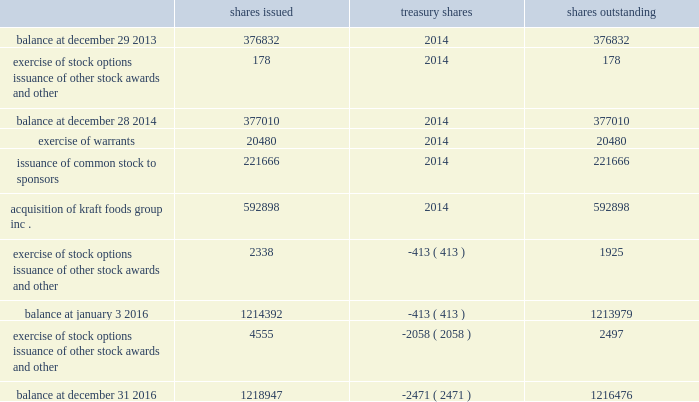Shares of common stock issued , in treasury , and outstanding were ( in thousands of shares ) : .
Note 13 .
Financing arrangements we routinely enter into accounts receivable securitization and factoring programs .
We account for transfers of receivables pursuant to these programs as a sale and remove them from our consolidated balance sheet .
At december 31 , 2016 , our most significant program in place was the u.s .
Securitization program , which was amended in may 2016 and originally entered into in october of 2015 .
Under the program , we are entitled to receive cash consideration of up to $ 800 million ( which we elected to reduce to $ 500 million , effective february 21 , 2017 ) and a receivable for the remainder of the purchase price ( the 201cdeferred purchase price 201d ) .
This securitization program utilizes a bankruptcy- remote special-purpose entity ( 201cspe 201d ) .
The spe is wholly-owned by a subsidiary of kraft heinz and its sole business consists of the purchase or acceptance , through capital contributions of receivables and related assets , from a kraft heinz subsidiary and subsequent transfer of such receivables and related assets to a bank .
Although the spe is included in our consolidated financial statements , it is a separate legal entity with separate creditors who will be entitled , upon its liquidation , to be satisfied out of the spe's assets prior to any assets or value in the spe becoming available to kraft heinz or its subsidiaries .
The assets of the spe are not available to pay creditors of kraft heinz or its subsidiaries .
This program expires in may 2017 .
In addition to the u.s .
Securitization program , we have accounts receivable factoring programs denominated in australian dollars , new zealand dollars , british pound sterling , euros , and japanese yen .
Under these programs , we generally receive cash consideration up to a certain limit and a receivable for the deferred purchase price .
There is no deferred purchase price associated with the japanese yen contract .
Related to these programs , our aggregate cash consideration limit , after applying applicable hold-backs , was $ 245 million u.s .
Dollars at december 31 , 2016 .
Generally , each of these programs automatically renews annually until terminated by either party .
The cash consideration and carrying amount of receivables removed from the consolidated balance sheets in connection with the above programs were $ 904 million at december 31 , 2016 and $ 267 million at january 3 , 2016 .
The fair value of the deferred purchase price for the programs was $ 129 million at december 31 , 2016 and $ 583 million at january 3 , 2016 .
The deferred purchase price is included in sold receivables on the consolidated balance sheets and had a carrying value which approximated its fair value at december 31 , 2016 and january 3 , 2016 .
The proceeds from these sales are recognized on the consolidated statements of cash flows as a component of operating activities .
We act as servicer for these arrangements and have not recorded any servicing assets or liabilities for these arrangements as of december 31 , 2016 and january 3 , 2016 because they were not material to the financial statements. .
What portion of the issued shares is reported as treasury stock as of december 31 , 2016? 
Computations: (2471 / 1218947)
Answer: 0.00203. 